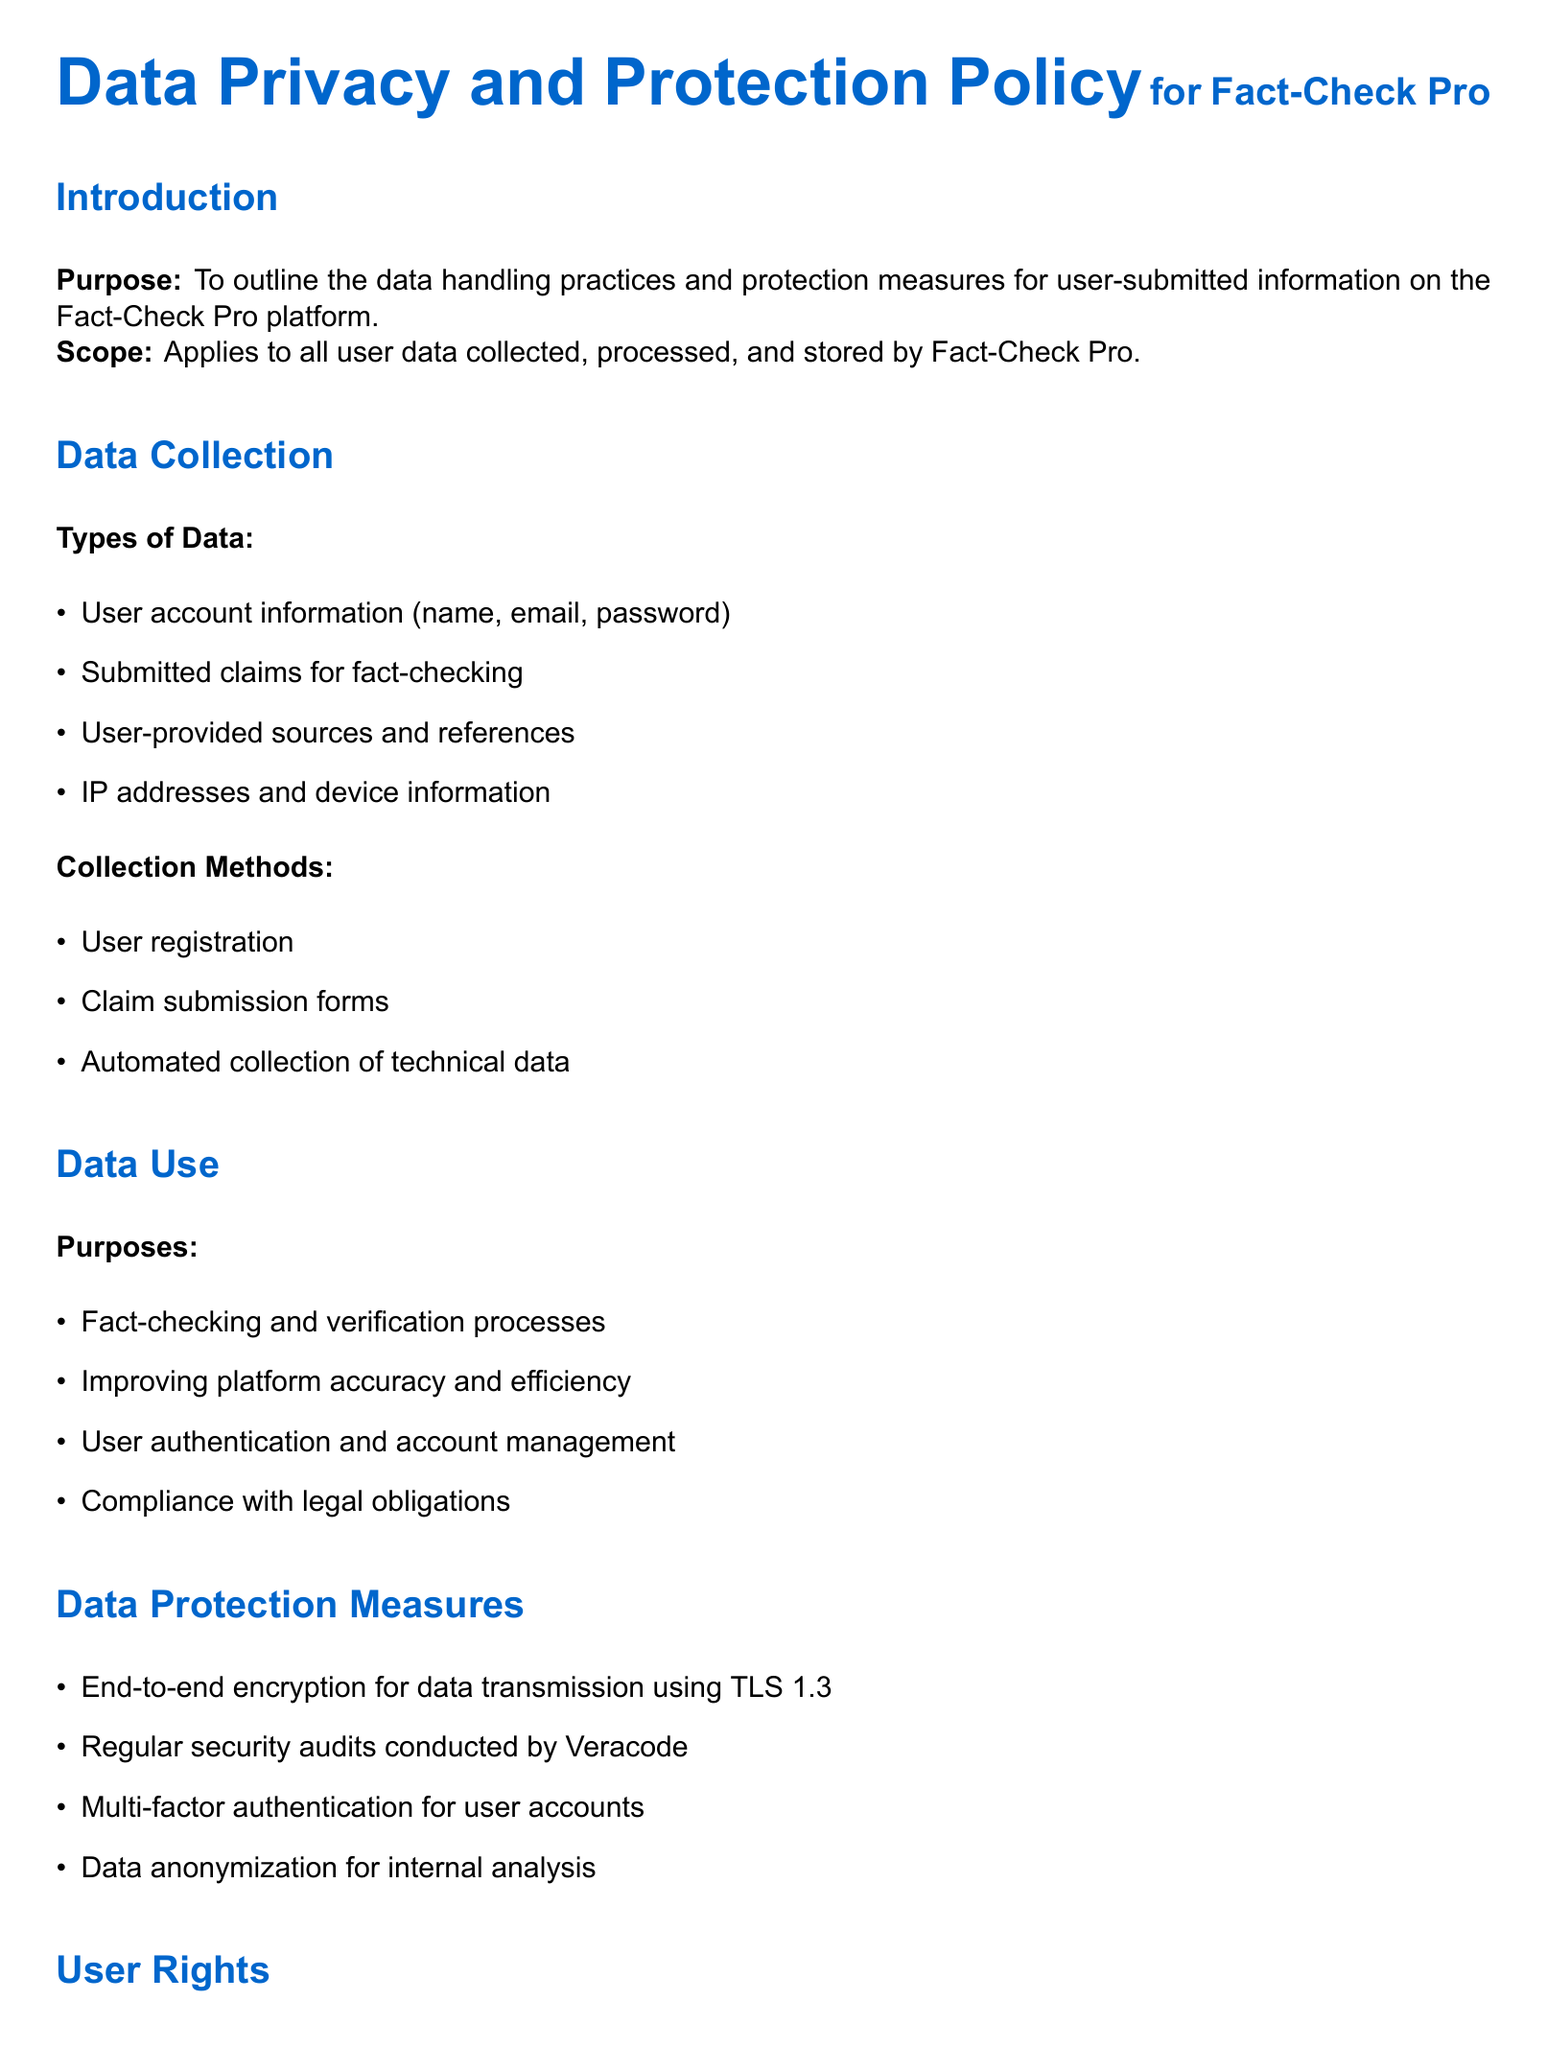What is the purpose of the data privacy policy? The purpose outlines the data handling practices and protection measures for user-submitted information on the platform.
Answer: To outline the data handling practices and protection measures What types of data are collected? This identifies the specific categories of user information collected by the platform.
Answer: User account information, submitted claims, user-provided sources, IP addresses, device information How long is user data retained? This specifies the duration for which user data will be kept after their last activity.
Answer: 2 years What are the conditions for third-party sharing? This includes the specific circumstances under which user information can be shared with third parties.
Answer: Only with user consent, for legal compliance, with trusted partners What is one protection measure mentioned for data? This identifies a specific security practice aimed at protecting user data on the platform.
Answer: End-to-end encryption for data transmission using TLS 1.3 What user right allows them to delete their personal data? This refers to the specific entitlement that enables users to request the removal of their data.
Answer: Right to be forgotten Who is the Data Protection Officer? This identifies the person responsible for data protection matters within the organization.
Answer: privacy@factcheckpro.com How frequently is the policy updated? This details how often the policy undergoes review and revisions.
Answer: Annual review and update 